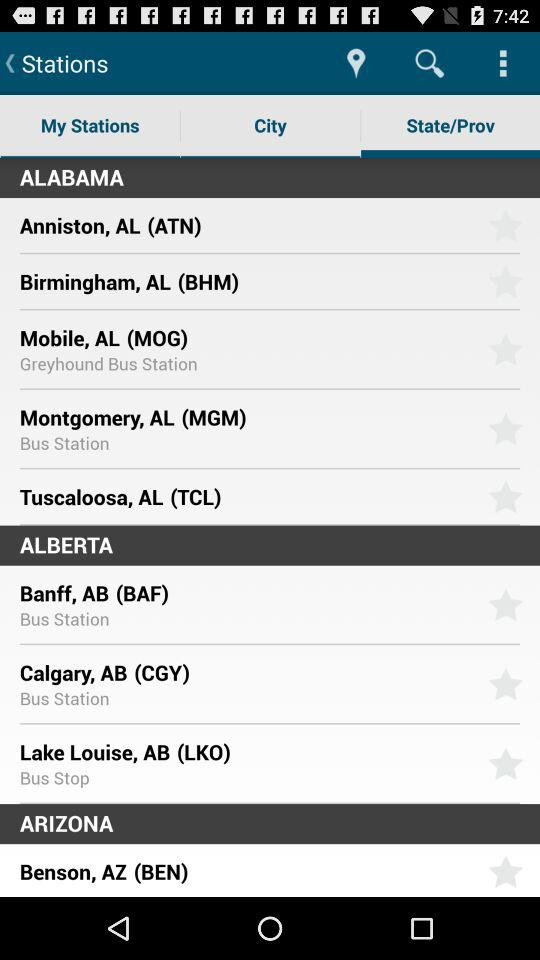Which is the selected tab? The selected tab is "State/Prov". 